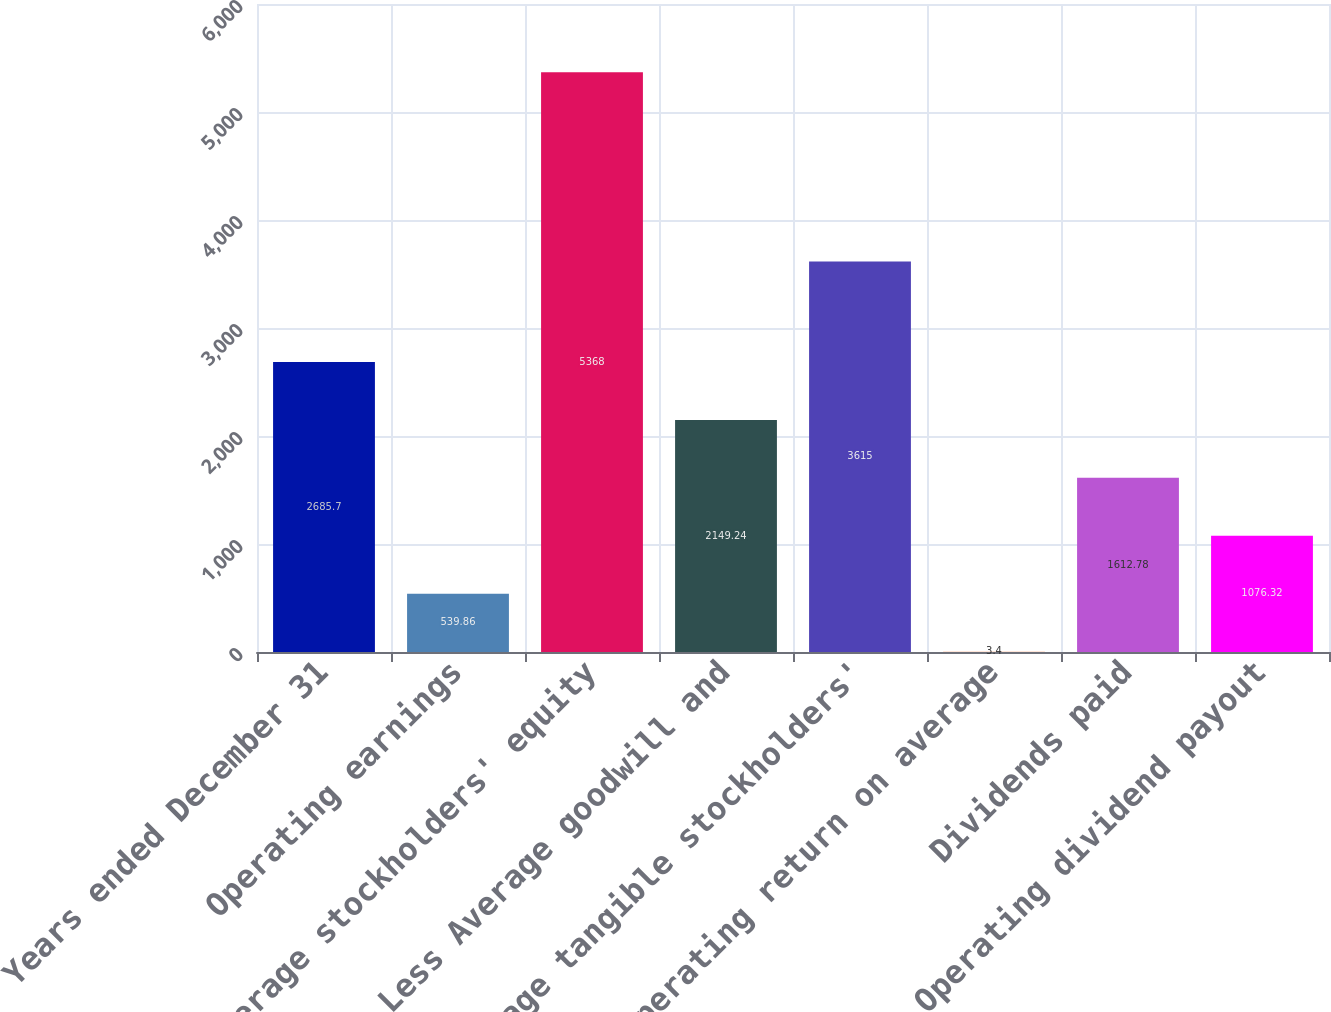Convert chart. <chart><loc_0><loc_0><loc_500><loc_500><bar_chart><fcel>Years ended December 31<fcel>Operating earnings<fcel>Average stockholders' equity<fcel>Less Average goodwill and<fcel>Average tangible stockholders'<fcel>Operating return on average<fcel>Dividends paid<fcel>Operating dividend payout<nl><fcel>2685.7<fcel>539.86<fcel>5368<fcel>2149.24<fcel>3615<fcel>3.4<fcel>1612.78<fcel>1076.32<nl></chart> 